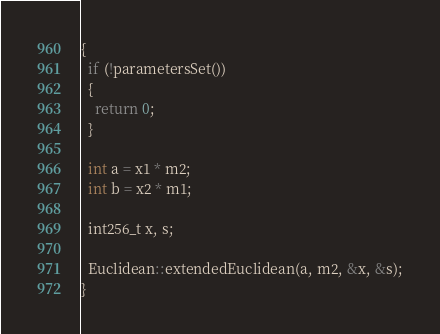<code> <loc_0><loc_0><loc_500><loc_500><_C++_>{
  if (!parametersSet())
  {
    return 0;
  }

  int a = x1 * m2;
  int b = x2 * m1;

  int256_t x, s;

  Euclidean::extendedEuclidean(a, m2, &x, &s);
}</code> 